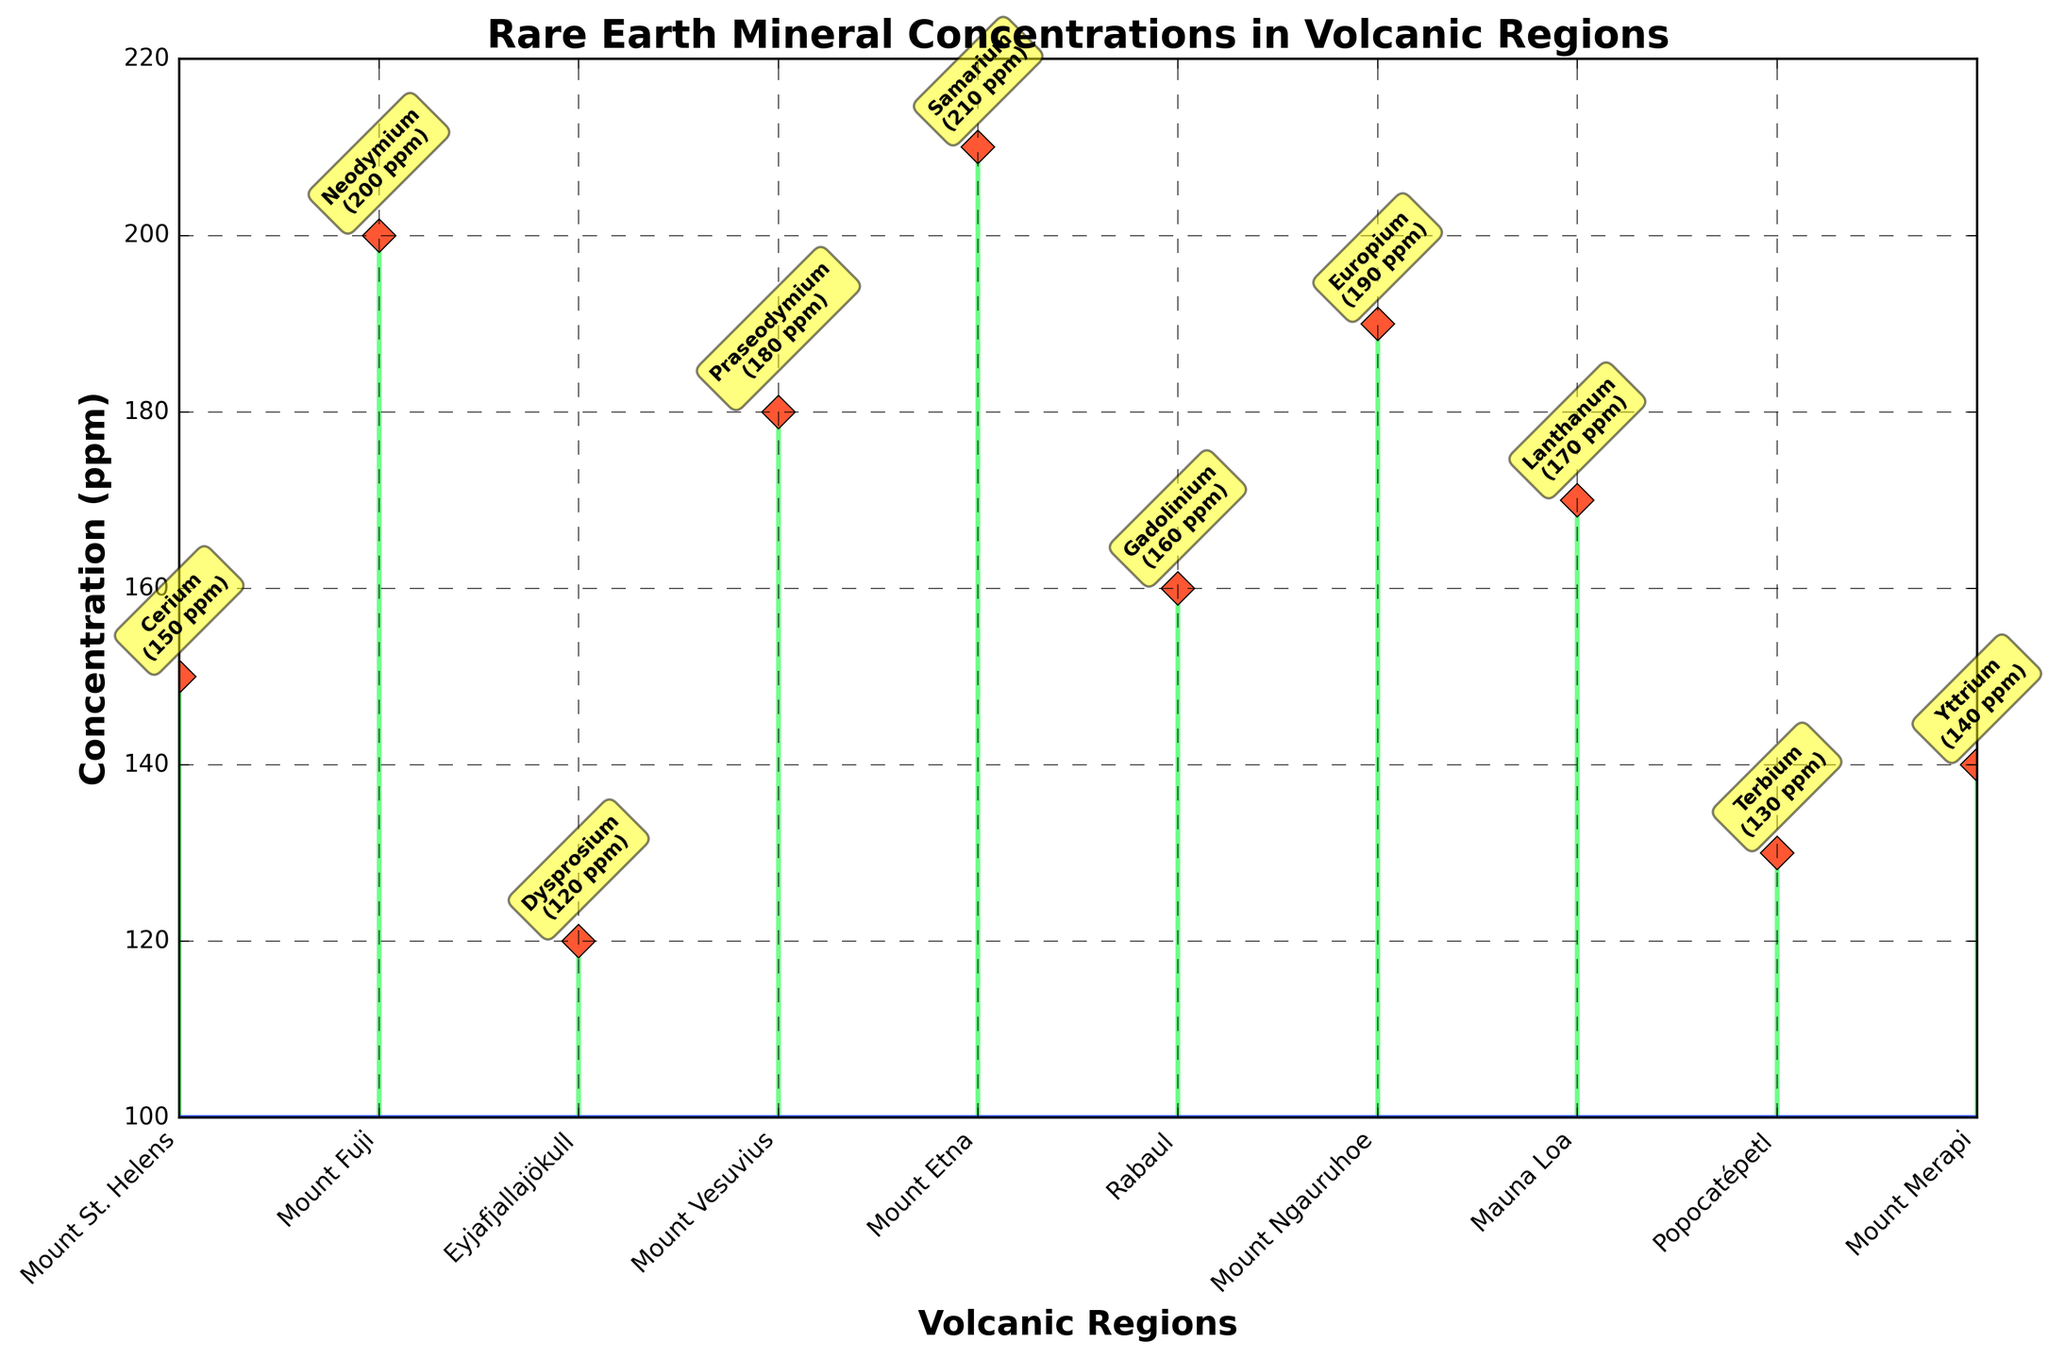What is the title of the figure? The title of the figure is usually located at the top of the plot. Here, it reads "Rare Earth Mineral Concentrations in Volcanic Regions".
Answer: Rare Earth Mineral Concentrations in Volcanic Regions What are the x-axis and y-axis labels? The x-axis label is found horizontally along the bottom of the plot and it reads "Volcanic Regions". The y-axis label is found vertically along the left side of the plot and it reads "Concentration (ppm)".
Answer: Volcanic Regions, Concentration (ppm) Which volcanic region has the highest concentration of rare earth minerals? The region with the highest point on the y-axis has the highest concentration. The peak belongs to Mount Etna with 210 ppm of Samarium.
Answer: Mount Etna What is the concentration of Neodymium at Mount Fuji? Identify the point corresponding to Mount Fuji on the x-axis, then look at the annotated concentration above it. For Mount Fuji, the annotation shows 200 ppm for Neodymium.
Answer: 200 ppm Which volcanic region has the lowest concentration? Find the lowest vertical line in the plot. Eyjafjallajökull has the lowest concentration at 120 ppm for Dysprosium.
Answer: Eyjafjallajökull What is the difference in concentration between Dysprosium at Eyjafjallajökull and Samarium at Mount Etna? Eyjafjallajökull has 120 ppm of Dysprosium and Mount Etna has 210 ppm of Samarium. Subtract 120 from 210: 210 - 120 = 90 ppm.
Answer: 90 ppm How many volcanic regions have a concentration of rare earth minerals greater than 180 ppm? Count the number of vertical lines extending above the 180 ppm mark. They are Mount Fuji, Mount Vesuvius, Mount Etna, and Mount Ngauruhoe, so 4 regions.
Answer: 4 Which mineral is found at Mount Ngauruhoe and what is its concentration? Locate Mount Ngauruhoe on the x-axis and read the annotation. The mineral is Europium and its concentration is 190 ppm.
Answer: Europium, 190 ppm What is the average concentration of rare earth minerals across all regions? Sum all concentrations and divide by the number of regions. (150 + 200 + 120 + 180 + 210 + 160 + 190 + 170 + 130 + 140) / 10 = 1650 / 10 = 165 ppm.
Answer: 165 ppm Which volcanic region has more Cerium: Mount St. Helens or Mount Merapi? Compare concentrations for each region. Mount St. Helens has 150 ppm of Cerium, while Mount Merapi has 140 ppm of Yttrium, so it's about comparison relevance. Only Mount St. Helens is associated with Cerium.
Answer: Mount St. Helens 